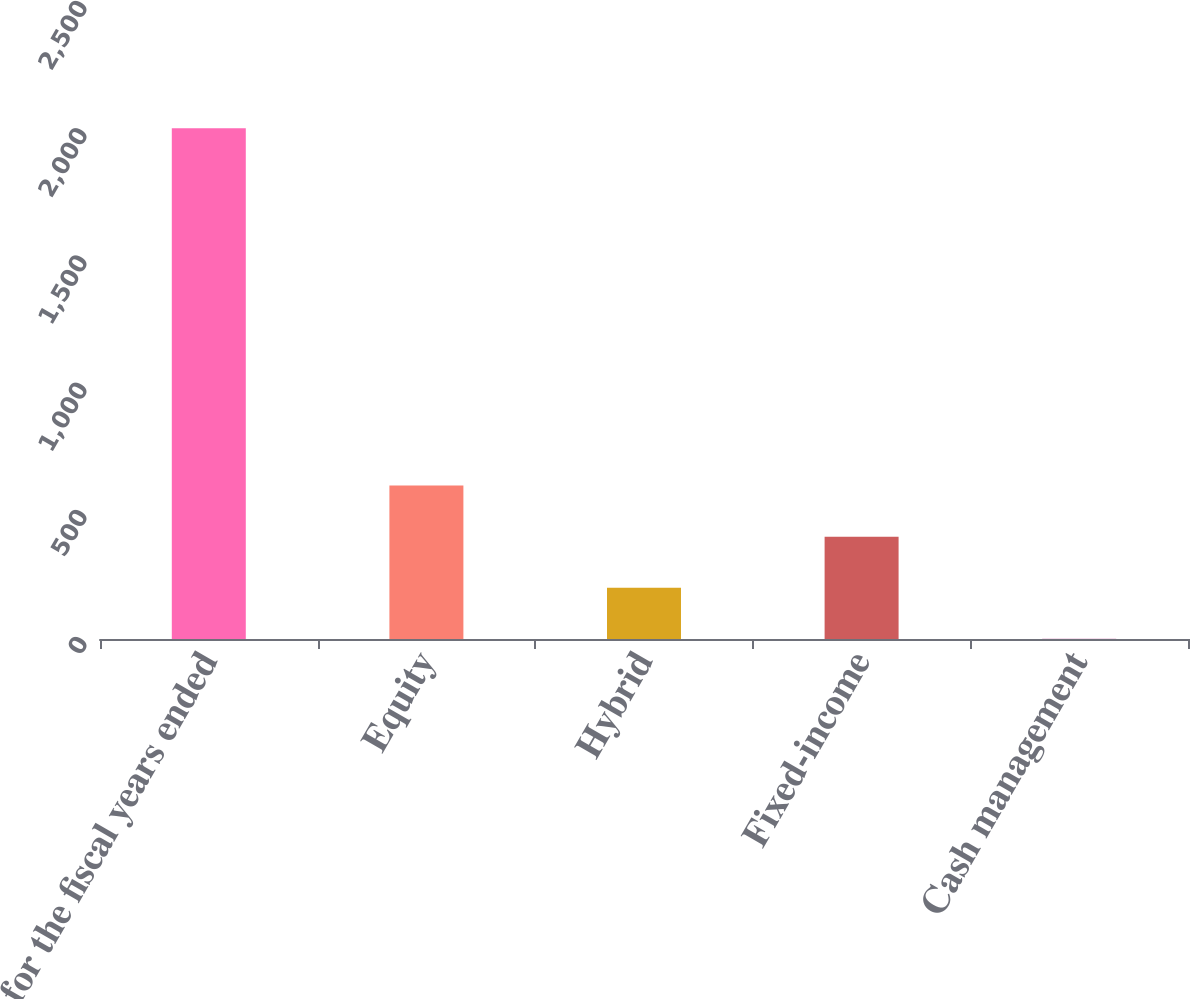<chart> <loc_0><loc_0><loc_500><loc_500><bar_chart><fcel>for the fiscal years ended<fcel>Equity<fcel>Hybrid<fcel>Fixed-income<fcel>Cash management<nl><fcel>2008<fcel>603.1<fcel>201.7<fcel>402.4<fcel>1<nl></chart> 